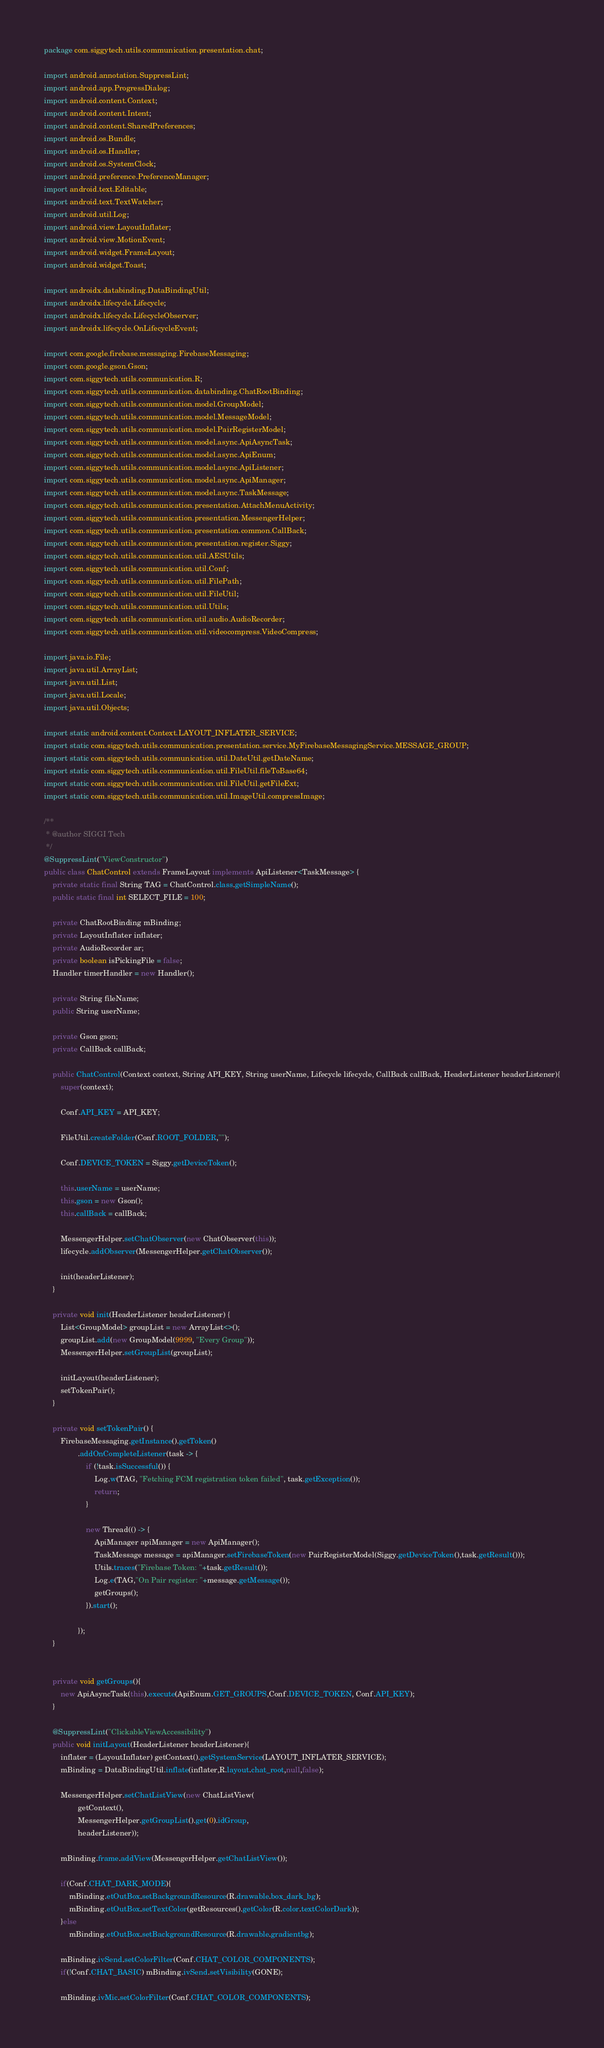<code> <loc_0><loc_0><loc_500><loc_500><_Java_>package com.siggytech.utils.communication.presentation.chat;

import android.annotation.SuppressLint;
import android.app.ProgressDialog;
import android.content.Context;
import android.content.Intent;
import android.content.SharedPreferences;
import android.os.Bundle;
import android.os.Handler;
import android.os.SystemClock;
import android.preference.PreferenceManager;
import android.text.Editable;
import android.text.TextWatcher;
import android.util.Log;
import android.view.LayoutInflater;
import android.view.MotionEvent;
import android.widget.FrameLayout;
import android.widget.Toast;

import androidx.databinding.DataBindingUtil;
import androidx.lifecycle.Lifecycle;
import androidx.lifecycle.LifecycleObserver;
import androidx.lifecycle.OnLifecycleEvent;

import com.google.firebase.messaging.FirebaseMessaging;
import com.google.gson.Gson;
import com.siggytech.utils.communication.R;
import com.siggytech.utils.communication.databinding.ChatRootBinding;
import com.siggytech.utils.communication.model.GroupModel;
import com.siggytech.utils.communication.model.MessageModel;
import com.siggytech.utils.communication.model.PairRegisterModel;
import com.siggytech.utils.communication.model.async.ApiAsyncTask;
import com.siggytech.utils.communication.model.async.ApiEnum;
import com.siggytech.utils.communication.model.async.ApiListener;
import com.siggytech.utils.communication.model.async.ApiManager;
import com.siggytech.utils.communication.model.async.TaskMessage;
import com.siggytech.utils.communication.presentation.AttachMenuActivity;
import com.siggytech.utils.communication.presentation.MessengerHelper;
import com.siggytech.utils.communication.presentation.common.CallBack;
import com.siggytech.utils.communication.presentation.register.Siggy;
import com.siggytech.utils.communication.util.AESUtils;
import com.siggytech.utils.communication.util.Conf;
import com.siggytech.utils.communication.util.FilePath;
import com.siggytech.utils.communication.util.FileUtil;
import com.siggytech.utils.communication.util.Utils;
import com.siggytech.utils.communication.util.audio.AudioRecorder;
import com.siggytech.utils.communication.util.videocompress.VideoCompress;

import java.io.File;
import java.util.ArrayList;
import java.util.List;
import java.util.Locale;
import java.util.Objects;

import static android.content.Context.LAYOUT_INFLATER_SERVICE;
import static com.siggytech.utils.communication.presentation.service.MyFirebaseMessagingService.MESSAGE_GROUP;
import static com.siggytech.utils.communication.util.DateUtil.getDateName;
import static com.siggytech.utils.communication.util.FileUtil.fileToBase64;
import static com.siggytech.utils.communication.util.FileUtil.getFileExt;
import static com.siggytech.utils.communication.util.ImageUtil.compressImage;

/**
 * @author SIGGI Tech
 */
@SuppressLint("ViewConstructor")
public class ChatControl extends FrameLayout implements ApiListener<TaskMessage> {
    private static final String TAG = ChatControl.class.getSimpleName();
    public static final int SELECT_FILE = 100;

    private ChatRootBinding mBinding;
    private LayoutInflater inflater;
    private AudioRecorder ar;
    private boolean isPickingFile = false;
    Handler timerHandler = new Handler();

    private String fileName;
    public String userName;

    private Gson gson;
    private CallBack callBack;

    public ChatControl(Context context, String API_KEY, String userName, Lifecycle lifecycle, CallBack callBack, HeaderListener headerListener){
        super(context);

        Conf.API_KEY = API_KEY;

        FileUtil.createFolder(Conf.ROOT_FOLDER,"");

        Conf.DEVICE_TOKEN = Siggy.getDeviceToken();

        this.userName = userName;
        this.gson = new Gson();
        this.callBack = callBack;

        MessengerHelper.setChatObserver(new ChatObserver(this));
        lifecycle.addObserver(MessengerHelper.getChatObserver());

        init(headerListener);
    }

    private void init(HeaderListener headerListener) {
        List<GroupModel> groupList = new ArrayList<>();
        groupList.add(new GroupModel(9999, "Every Group"));
        MessengerHelper.setGroupList(groupList);

        initLayout(headerListener);
        setTokenPair();
    }

    private void setTokenPair() {
        FirebaseMessaging.getInstance().getToken()
                .addOnCompleteListener(task -> {
                    if (!task.isSuccessful()) {
                        Log.w(TAG, "Fetching FCM registration token failed", task.getException());
                        return;
                    }

                    new Thread(() -> {
                        ApiManager apiManager = new ApiManager();
                        TaskMessage message = apiManager.setFirebaseToken(new PairRegisterModel(Siggy.getDeviceToken(),task.getResult()));
                        Utils.traces("Firebase Token: "+task.getResult());
                        Log.e(TAG,"On Pair register: "+message.getMessage());
                        getGroups();
                    }).start();

                });
    }


    private void getGroups(){
        new ApiAsyncTask(this).execute(ApiEnum.GET_GROUPS,Conf.DEVICE_TOKEN, Conf.API_KEY);
    }

    @SuppressLint("ClickableViewAccessibility")
    public void initLayout(HeaderListener headerListener){
        inflater = (LayoutInflater) getContext().getSystemService(LAYOUT_INFLATER_SERVICE);
        mBinding = DataBindingUtil.inflate(inflater,R.layout.chat_root,null,false);

        MessengerHelper.setChatListView(new ChatListView(
                getContext(),
                MessengerHelper.getGroupList().get(0).idGroup,
                headerListener));

        mBinding.frame.addView(MessengerHelper.getChatListView());

        if(Conf.CHAT_DARK_MODE){
            mBinding.etOutBox.setBackgroundResource(R.drawable.box_dark_bg);
            mBinding.etOutBox.setTextColor(getResources().getColor(R.color.textColorDark));
        }else
            mBinding.etOutBox.setBackgroundResource(R.drawable.gradientbg);

        mBinding.ivSend.setColorFilter(Conf.CHAT_COLOR_COMPONENTS);
        if(!Conf.CHAT_BASIC) mBinding.ivSend.setVisibility(GONE);

        mBinding.ivMic.setColorFilter(Conf.CHAT_COLOR_COMPONENTS);</code> 